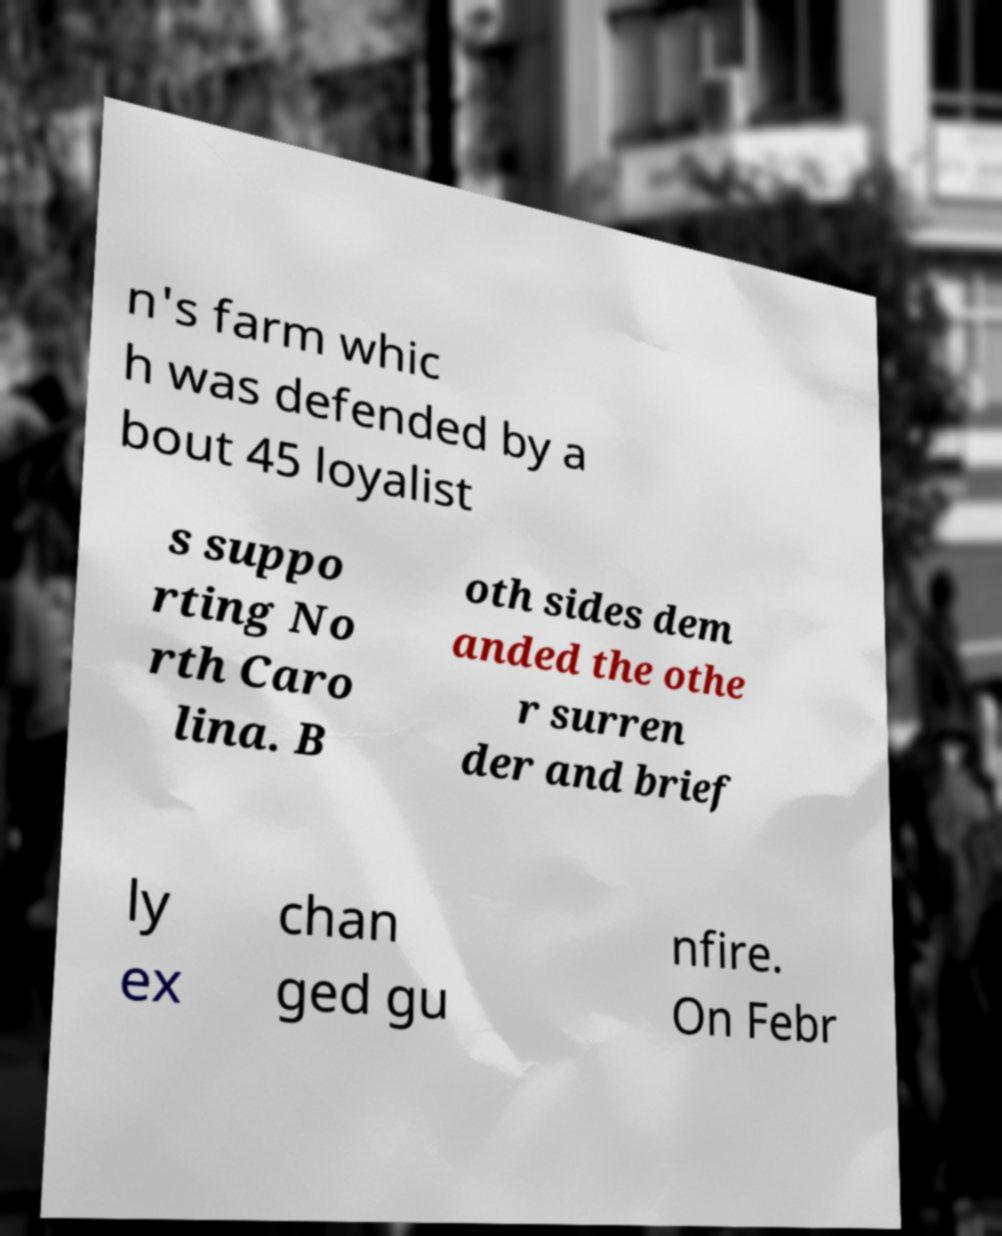Can you read and provide the text displayed in the image?This photo seems to have some interesting text. Can you extract and type it out for me? n's farm whic h was defended by a bout 45 loyalist s suppo rting No rth Caro lina. B oth sides dem anded the othe r surren der and brief ly ex chan ged gu nfire. On Febr 